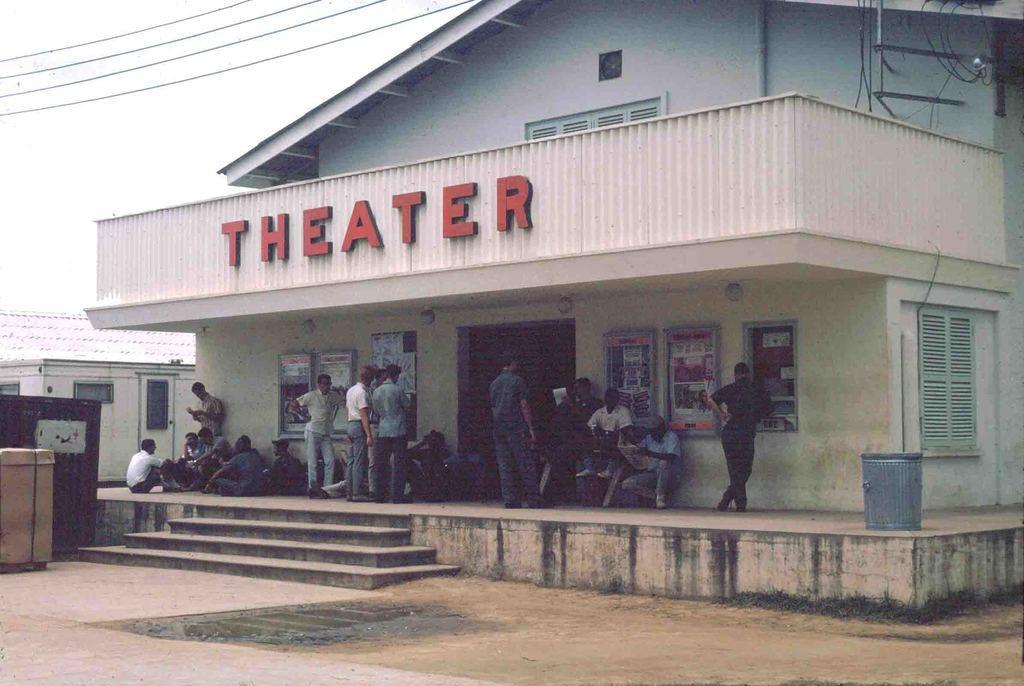Please provide a concise description of this image. In this picture I can see group of people standing and sitting. There are buildings, boards, cables and some other objects, and in the background there is the sky. 